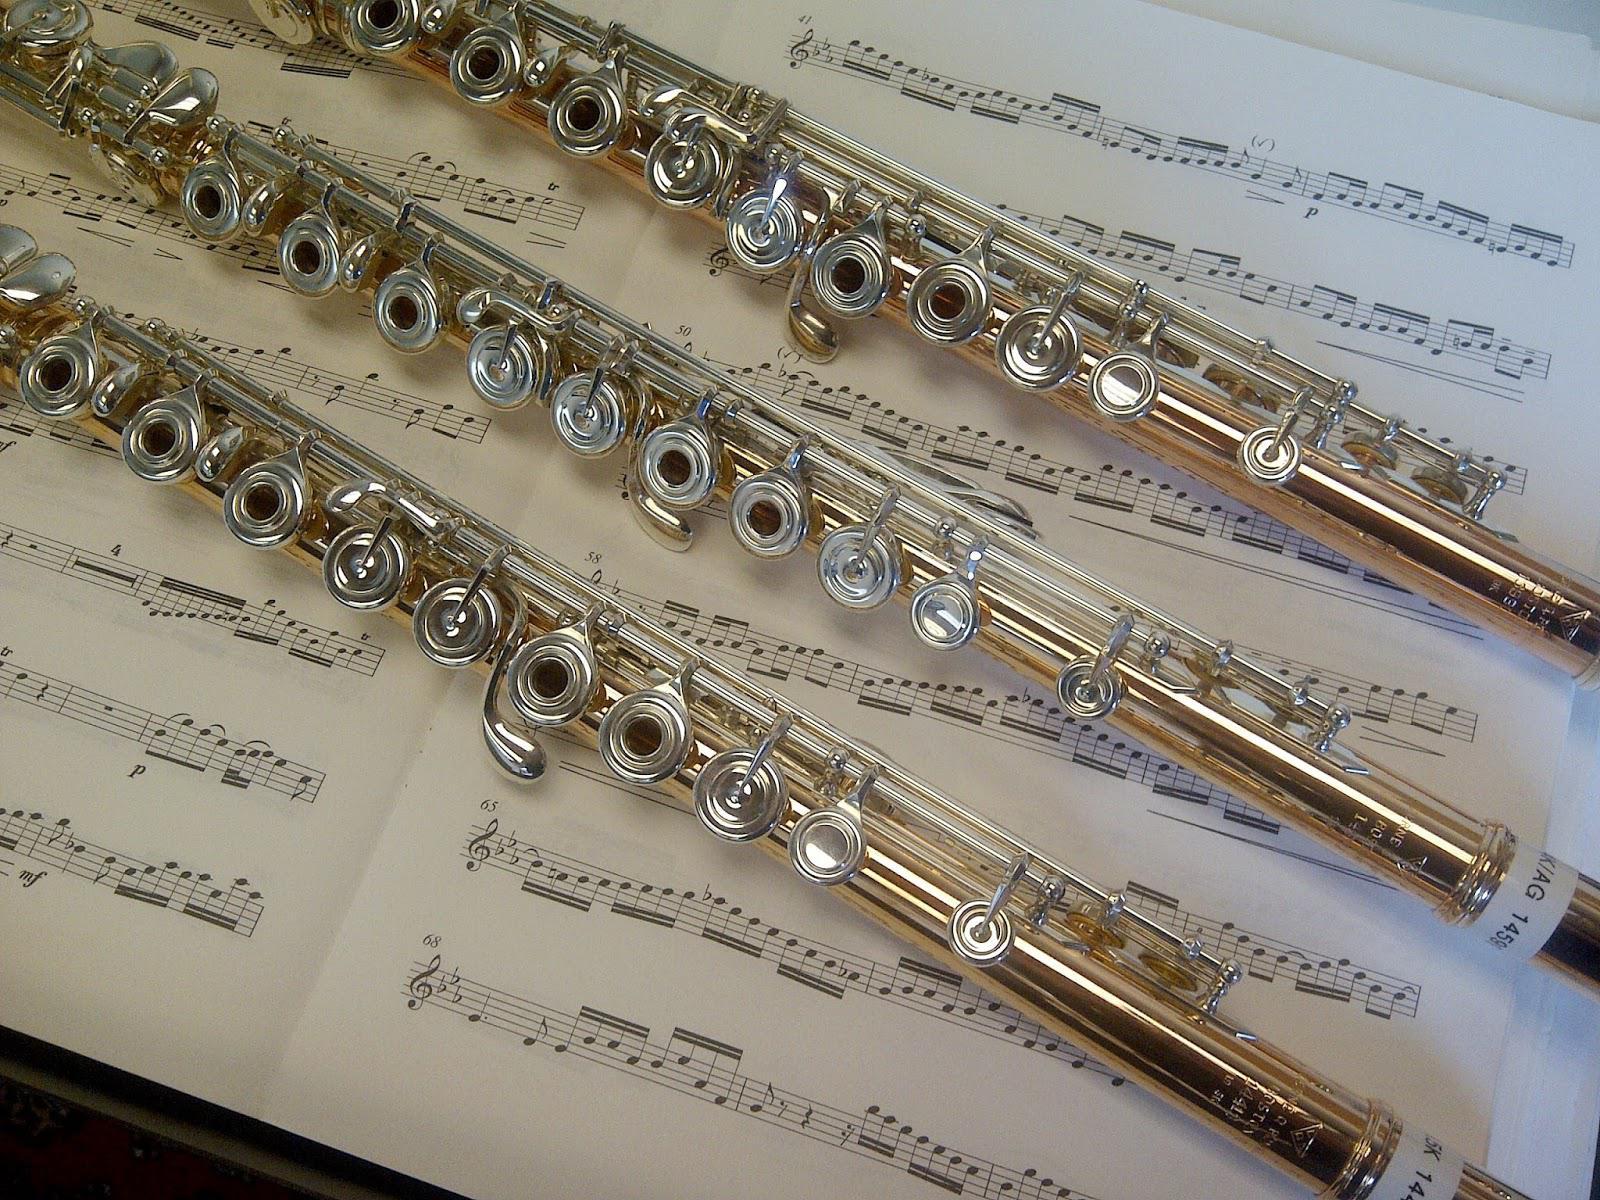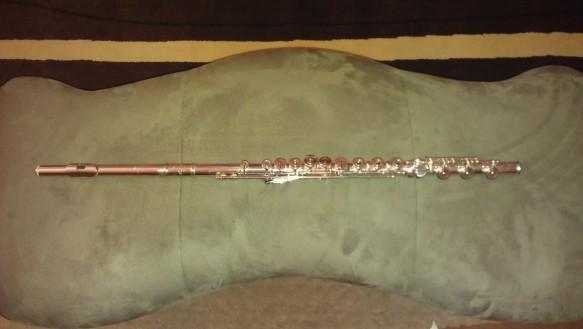The first image is the image on the left, the second image is the image on the right. Evaluate the accuracy of this statement regarding the images: "IN at least one image there is a flute end sitting on a squarded rock.". Is it true? Answer yes or no. No. The first image is the image on the left, the second image is the image on the right. Analyze the images presented: Is the assertion "An image shows a wooden flute with its mouthpiece end propped up and with a carved animal figure above a tassel tie." valid? Answer yes or no. No. 